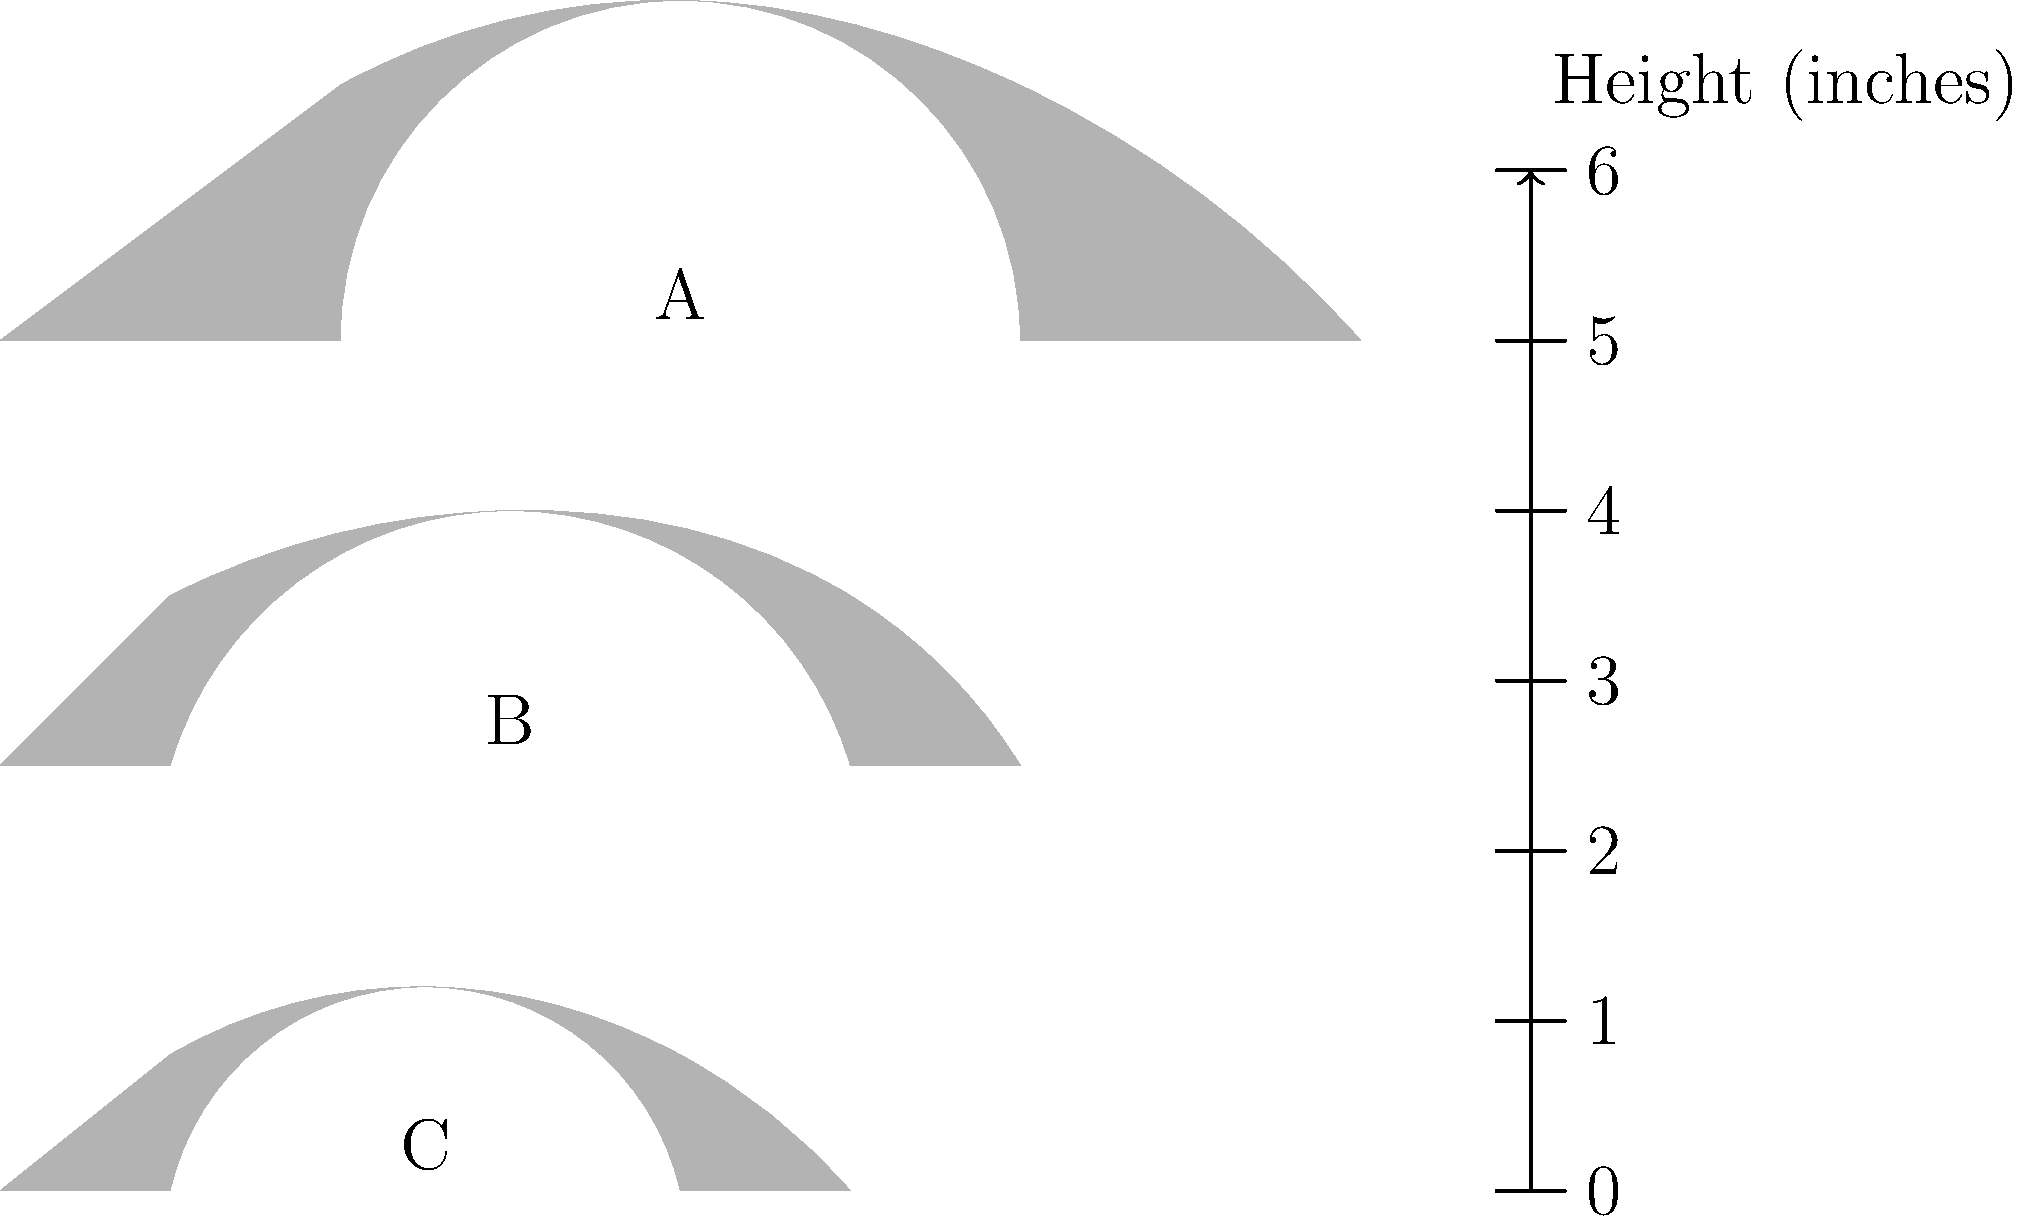As an editor working on a book about Wild West legends, you come across a diagram comparing the silhouettes of different types of cowboy hats. Based on the given scale, which hat has the largest brim width, and approximately how wide is it in inches? To answer this question, we need to analyze the silhouettes of the three hats shown in the diagram and compare their brim widths:

1. Hat A (Sombrero): This hat has the widest brim, extending significantly beyond the crown.
2. Hat B (Traditional Cowboy Hat): This hat has a moderate brim width.
3. Hat C (Bowler): This hat has the narrowest brim of the three.

To determine the approximate width of the largest brim:

1. Identify that Hat A (Sombrero) has the largest brim.
2. Estimate the width of the brim by comparing it to the provided scale.
3. The sombrero's total width appears to be about 8 units on the scale.
4. The crown (center part) of the hat is approximately 4 units wide.
5. The brim extends on each side, so we calculate: (Total width - Crown width) / 2
   $(8 - 4) / 2 = 2$ inches on each side
6. Therefore, the total brim width (both sides combined) is approximately 4 inches.

This estimation aligns with historical accuracy, as sombreros were known for their exceptionally wide brims, often reaching up to 6 inches or more, designed to provide maximum sun protection in the arid environments of the American Southwest and Mexico.
Answer: Hat A (Sombrero), approximately 4 inches 